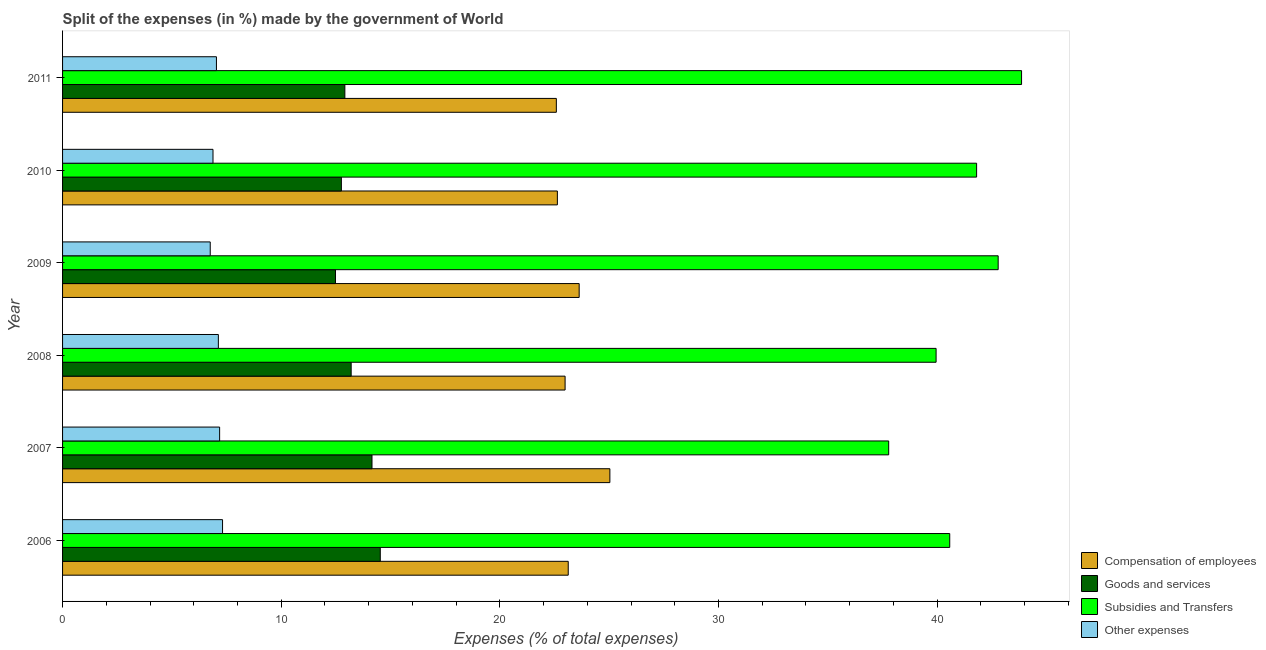How many groups of bars are there?
Your response must be concise. 6. How many bars are there on the 4th tick from the top?
Your response must be concise. 4. In how many cases, is the number of bars for a given year not equal to the number of legend labels?
Offer a terse response. 0. What is the percentage of amount spent on compensation of employees in 2011?
Offer a very short reply. 22.58. Across all years, what is the maximum percentage of amount spent on goods and services?
Ensure brevity in your answer.  14.53. Across all years, what is the minimum percentage of amount spent on other expenses?
Provide a short and direct response. 6.75. In which year was the percentage of amount spent on other expenses maximum?
Your answer should be very brief. 2006. What is the total percentage of amount spent on goods and services in the graph?
Your answer should be compact. 80.03. What is the difference between the percentage of amount spent on other expenses in 2006 and that in 2008?
Offer a terse response. 0.19. What is the difference between the percentage of amount spent on compensation of employees in 2006 and the percentage of amount spent on other expenses in 2011?
Make the answer very short. 16.09. What is the average percentage of amount spent on goods and services per year?
Keep it short and to the point. 13.34. In the year 2010, what is the difference between the percentage of amount spent on subsidies and percentage of amount spent on goods and services?
Your answer should be compact. 29.05. What is the ratio of the percentage of amount spent on goods and services in 2006 to that in 2007?
Your answer should be compact. 1.03. What is the difference between the highest and the second highest percentage of amount spent on goods and services?
Your answer should be compact. 0.38. What is the difference between the highest and the lowest percentage of amount spent on compensation of employees?
Keep it short and to the point. 2.45. In how many years, is the percentage of amount spent on goods and services greater than the average percentage of amount spent on goods and services taken over all years?
Keep it short and to the point. 2. What does the 4th bar from the top in 2008 represents?
Make the answer very short. Compensation of employees. What does the 4th bar from the bottom in 2010 represents?
Your answer should be very brief. Other expenses. How many bars are there?
Provide a succinct answer. 24. Are all the bars in the graph horizontal?
Offer a terse response. Yes. How many years are there in the graph?
Your answer should be very brief. 6. What is the difference between two consecutive major ticks on the X-axis?
Your answer should be compact. 10. Are the values on the major ticks of X-axis written in scientific E-notation?
Your answer should be very brief. No. Does the graph contain any zero values?
Your answer should be compact. No. Where does the legend appear in the graph?
Offer a very short reply. Bottom right. How many legend labels are there?
Provide a succinct answer. 4. How are the legend labels stacked?
Provide a succinct answer. Vertical. What is the title of the graph?
Make the answer very short. Split of the expenses (in %) made by the government of World. What is the label or title of the X-axis?
Provide a succinct answer. Expenses (% of total expenses). What is the label or title of the Y-axis?
Your answer should be very brief. Year. What is the Expenses (% of total expenses) in Compensation of employees in 2006?
Your answer should be very brief. 23.13. What is the Expenses (% of total expenses) in Goods and services in 2006?
Make the answer very short. 14.53. What is the Expenses (% of total expenses) of Subsidies and Transfers in 2006?
Give a very brief answer. 40.58. What is the Expenses (% of total expenses) of Other expenses in 2006?
Offer a terse response. 7.32. What is the Expenses (% of total expenses) of Compensation of employees in 2007?
Offer a terse response. 25.03. What is the Expenses (% of total expenses) of Goods and services in 2007?
Your answer should be compact. 14.15. What is the Expenses (% of total expenses) of Subsidies and Transfers in 2007?
Provide a succinct answer. 37.79. What is the Expenses (% of total expenses) of Other expenses in 2007?
Give a very brief answer. 7.18. What is the Expenses (% of total expenses) of Compensation of employees in 2008?
Your answer should be very brief. 22.98. What is the Expenses (% of total expenses) of Goods and services in 2008?
Make the answer very short. 13.2. What is the Expenses (% of total expenses) in Subsidies and Transfers in 2008?
Keep it short and to the point. 39.95. What is the Expenses (% of total expenses) in Other expenses in 2008?
Your response must be concise. 7.13. What is the Expenses (% of total expenses) in Compensation of employees in 2009?
Provide a short and direct response. 23.63. What is the Expenses (% of total expenses) in Goods and services in 2009?
Provide a succinct answer. 12.48. What is the Expenses (% of total expenses) in Subsidies and Transfers in 2009?
Give a very brief answer. 42.79. What is the Expenses (% of total expenses) in Other expenses in 2009?
Your response must be concise. 6.75. What is the Expenses (% of total expenses) in Compensation of employees in 2010?
Keep it short and to the point. 22.63. What is the Expenses (% of total expenses) in Goods and services in 2010?
Provide a succinct answer. 12.75. What is the Expenses (% of total expenses) in Subsidies and Transfers in 2010?
Provide a succinct answer. 41.81. What is the Expenses (% of total expenses) of Other expenses in 2010?
Your answer should be compact. 6.88. What is the Expenses (% of total expenses) in Compensation of employees in 2011?
Provide a short and direct response. 22.58. What is the Expenses (% of total expenses) of Goods and services in 2011?
Make the answer very short. 12.91. What is the Expenses (% of total expenses) of Subsidies and Transfers in 2011?
Keep it short and to the point. 43.86. What is the Expenses (% of total expenses) in Other expenses in 2011?
Provide a succinct answer. 7.04. Across all years, what is the maximum Expenses (% of total expenses) in Compensation of employees?
Ensure brevity in your answer.  25.03. Across all years, what is the maximum Expenses (% of total expenses) of Goods and services?
Offer a very short reply. 14.53. Across all years, what is the maximum Expenses (% of total expenses) of Subsidies and Transfers?
Your response must be concise. 43.86. Across all years, what is the maximum Expenses (% of total expenses) in Other expenses?
Your answer should be compact. 7.32. Across all years, what is the minimum Expenses (% of total expenses) in Compensation of employees?
Your answer should be compact. 22.58. Across all years, what is the minimum Expenses (% of total expenses) in Goods and services?
Ensure brevity in your answer.  12.48. Across all years, what is the minimum Expenses (% of total expenses) of Subsidies and Transfers?
Give a very brief answer. 37.79. Across all years, what is the minimum Expenses (% of total expenses) of Other expenses?
Your answer should be compact. 6.75. What is the total Expenses (% of total expenses) in Compensation of employees in the graph?
Your answer should be compact. 139.99. What is the total Expenses (% of total expenses) of Goods and services in the graph?
Make the answer very short. 80.03. What is the total Expenses (% of total expenses) of Subsidies and Transfers in the graph?
Offer a very short reply. 246.78. What is the total Expenses (% of total expenses) in Other expenses in the graph?
Provide a succinct answer. 42.3. What is the difference between the Expenses (% of total expenses) of Compensation of employees in 2006 and that in 2007?
Make the answer very short. -1.9. What is the difference between the Expenses (% of total expenses) in Goods and services in 2006 and that in 2007?
Ensure brevity in your answer.  0.38. What is the difference between the Expenses (% of total expenses) of Subsidies and Transfers in 2006 and that in 2007?
Give a very brief answer. 2.79. What is the difference between the Expenses (% of total expenses) in Other expenses in 2006 and that in 2007?
Provide a short and direct response. 0.13. What is the difference between the Expenses (% of total expenses) of Compensation of employees in 2006 and that in 2008?
Give a very brief answer. 0.14. What is the difference between the Expenses (% of total expenses) of Goods and services in 2006 and that in 2008?
Ensure brevity in your answer.  1.33. What is the difference between the Expenses (% of total expenses) in Subsidies and Transfers in 2006 and that in 2008?
Ensure brevity in your answer.  0.62. What is the difference between the Expenses (% of total expenses) of Other expenses in 2006 and that in 2008?
Give a very brief answer. 0.19. What is the difference between the Expenses (% of total expenses) of Compensation of employees in 2006 and that in 2009?
Make the answer very short. -0.5. What is the difference between the Expenses (% of total expenses) of Goods and services in 2006 and that in 2009?
Offer a very short reply. 2.05. What is the difference between the Expenses (% of total expenses) of Subsidies and Transfers in 2006 and that in 2009?
Your answer should be very brief. -2.22. What is the difference between the Expenses (% of total expenses) in Other expenses in 2006 and that in 2009?
Give a very brief answer. 0.56. What is the difference between the Expenses (% of total expenses) of Compensation of employees in 2006 and that in 2010?
Your answer should be very brief. 0.5. What is the difference between the Expenses (% of total expenses) of Goods and services in 2006 and that in 2010?
Make the answer very short. 1.78. What is the difference between the Expenses (% of total expenses) in Subsidies and Transfers in 2006 and that in 2010?
Provide a short and direct response. -1.23. What is the difference between the Expenses (% of total expenses) in Other expenses in 2006 and that in 2010?
Offer a very short reply. 0.44. What is the difference between the Expenses (% of total expenses) in Compensation of employees in 2006 and that in 2011?
Provide a short and direct response. 0.54. What is the difference between the Expenses (% of total expenses) in Goods and services in 2006 and that in 2011?
Your response must be concise. 1.62. What is the difference between the Expenses (% of total expenses) of Subsidies and Transfers in 2006 and that in 2011?
Provide a succinct answer. -3.29. What is the difference between the Expenses (% of total expenses) in Other expenses in 2006 and that in 2011?
Your answer should be compact. 0.28. What is the difference between the Expenses (% of total expenses) in Compensation of employees in 2007 and that in 2008?
Ensure brevity in your answer.  2.05. What is the difference between the Expenses (% of total expenses) of Goods and services in 2007 and that in 2008?
Your answer should be compact. 0.95. What is the difference between the Expenses (% of total expenses) in Subsidies and Transfers in 2007 and that in 2008?
Give a very brief answer. -2.17. What is the difference between the Expenses (% of total expenses) in Other expenses in 2007 and that in 2008?
Provide a short and direct response. 0.06. What is the difference between the Expenses (% of total expenses) in Compensation of employees in 2007 and that in 2009?
Provide a succinct answer. 1.4. What is the difference between the Expenses (% of total expenses) in Goods and services in 2007 and that in 2009?
Provide a succinct answer. 1.67. What is the difference between the Expenses (% of total expenses) of Subsidies and Transfers in 2007 and that in 2009?
Your answer should be very brief. -5.01. What is the difference between the Expenses (% of total expenses) of Other expenses in 2007 and that in 2009?
Your response must be concise. 0.43. What is the difference between the Expenses (% of total expenses) in Compensation of employees in 2007 and that in 2010?
Your answer should be very brief. 2.4. What is the difference between the Expenses (% of total expenses) of Goods and services in 2007 and that in 2010?
Make the answer very short. 1.4. What is the difference between the Expenses (% of total expenses) of Subsidies and Transfers in 2007 and that in 2010?
Offer a terse response. -4.02. What is the difference between the Expenses (% of total expenses) of Other expenses in 2007 and that in 2010?
Give a very brief answer. 0.3. What is the difference between the Expenses (% of total expenses) in Compensation of employees in 2007 and that in 2011?
Provide a succinct answer. 2.45. What is the difference between the Expenses (% of total expenses) in Goods and services in 2007 and that in 2011?
Your response must be concise. 1.24. What is the difference between the Expenses (% of total expenses) in Subsidies and Transfers in 2007 and that in 2011?
Provide a succinct answer. -6.08. What is the difference between the Expenses (% of total expenses) of Other expenses in 2007 and that in 2011?
Offer a very short reply. 0.15. What is the difference between the Expenses (% of total expenses) in Compensation of employees in 2008 and that in 2009?
Offer a very short reply. -0.64. What is the difference between the Expenses (% of total expenses) of Goods and services in 2008 and that in 2009?
Your answer should be compact. 0.72. What is the difference between the Expenses (% of total expenses) in Subsidies and Transfers in 2008 and that in 2009?
Your answer should be very brief. -2.84. What is the difference between the Expenses (% of total expenses) of Other expenses in 2008 and that in 2009?
Make the answer very short. 0.37. What is the difference between the Expenses (% of total expenses) in Compensation of employees in 2008 and that in 2010?
Ensure brevity in your answer.  0.35. What is the difference between the Expenses (% of total expenses) in Goods and services in 2008 and that in 2010?
Ensure brevity in your answer.  0.45. What is the difference between the Expenses (% of total expenses) of Subsidies and Transfers in 2008 and that in 2010?
Make the answer very short. -1.85. What is the difference between the Expenses (% of total expenses) of Other expenses in 2008 and that in 2010?
Ensure brevity in your answer.  0.24. What is the difference between the Expenses (% of total expenses) of Compensation of employees in 2008 and that in 2011?
Keep it short and to the point. 0.4. What is the difference between the Expenses (% of total expenses) in Goods and services in 2008 and that in 2011?
Make the answer very short. 0.29. What is the difference between the Expenses (% of total expenses) of Subsidies and Transfers in 2008 and that in 2011?
Make the answer very short. -3.91. What is the difference between the Expenses (% of total expenses) of Other expenses in 2008 and that in 2011?
Provide a short and direct response. 0.09. What is the difference between the Expenses (% of total expenses) of Compensation of employees in 2009 and that in 2010?
Your response must be concise. 1. What is the difference between the Expenses (% of total expenses) in Goods and services in 2009 and that in 2010?
Keep it short and to the point. -0.27. What is the difference between the Expenses (% of total expenses) of Other expenses in 2009 and that in 2010?
Keep it short and to the point. -0.13. What is the difference between the Expenses (% of total expenses) of Compensation of employees in 2009 and that in 2011?
Your answer should be very brief. 1.04. What is the difference between the Expenses (% of total expenses) in Goods and services in 2009 and that in 2011?
Ensure brevity in your answer.  -0.43. What is the difference between the Expenses (% of total expenses) of Subsidies and Transfers in 2009 and that in 2011?
Offer a very short reply. -1.07. What is the difference between the Expenses (% of total expenses) of Other expenses in 2009 and that in 2011?
Ensure brevity in your answer.  -0.28. What is the difference between the Expenses (% of total expenses) in Compensation of employees in 2010 and that in 2011?
Offer a terse response. 0.05. What is the difference between the Expenses (% of total expenses) in Goods and services in 2010 and that in 2011?
Your response must be concise. -0.16. What is the difference between the Expenses (% of total expenses) of Subsidies and Transfers in 2010 and that in 2011?
Your answer should be compact. -2.06. What is the difference between the Expenses (% of total expenses) in Other expenses in 2010 and that in 2011?
Provide a succinct answer. -0.16. What is the difference between the Expenses (% of total expenses) in Compensation of employees in 2006 and the Expenses (% of total expenses) in Goods and services in 2007?
Keep it short and to the point. 8.98. What is the difference between the Expenses (% of total expenses) in Compensation of employees in 2006 and the Expenses (% of total expenses) in Subsidies and Transfers in 2007?
Give a very brief answer. -14.66. What is the difference between the Expenses (% of total expenses) of Compensation of employees in 2006 and the Expenses (% of total expenses) of Other expenses in 2007?
Your answer should be compact. 15.94. What is the difference between the Expenses (% of total expenses) of Goods and services in 2006 and the Expenses (% of total expenses) of Subsidies and Transfers in 2007?
Ensure brevity in your answer.  -23.25. What is the difference between the Expenses (% of total expenses) of Goods and services in 2006 and the Expenses (% of total expenses) of Other expenses in 2007?
Ensure brevity in your answer.  7.35. What is the difference between the Expenses (% of total expenses) of Subsidies and Transfers in 2006 and the Expenses (% of total expenses) of Other expenses in 2007?
Keep it short and to the point. 33.39. What is the difference between the Expenses (% of total expenses) of Compensation of employees in 2006 and the Expenses (% of total expenses) of Goods and services in 2008?
Provide a short and direct response. 9.93. What is the difference between the Expenses (% of total expenses) of Compensation of employees in 2006 and the Expenses (% of total expenses) of Subsidies and Transfers in 2008?
Offer a very short reply. -16.83. What is the difference between the Expenses (% of total expenses) of Compensation of employees in 2006 and the Expenses (% of total expenses) of Other expenses in 2008?
Offer a very short reply. 16. What is the difference between the Expenses (% of total expenses) of Goods and services in 2006 and the Expenses (% of total expenses) of Subsidies and Transfers in 2008?
Your answer should be compact. -25.42. What is the difference between the Expenses (% of total expenses) of Goods and services in 2006 and the Expenses (% of total expenses) of Other expenses in 2008?
Offer a very short reply. 7.41. What is the difference between the Expenses (% of total expenses) of Subsidies and Transfers in 2006 and the Expenses (% of total expenses) of Other expenses in 2008?
Ensure brevity in your answer.  33.45. What is the difference between the Expenses (% of total expenses) of Compensation of employees in 2006 and the Expenses (% of total expenses) of Goods and services in 2009?
Your response must be concise. 10.65. What is the difference between the Expenses (% of total expenses) in Compensation of employees in 2006 and the Expenses (% of total expenses) in Subsidies and Transfers in 2009?
Provide a succinct answer. -19.66. What is the difference between the Expenses (% of total expenses) of Compensation of employees in 2006 and the Expenses (% of total expenses) of Other expenses in 2009?
Your answer should be compact. 16.37. What is the difference between the Expenses (% of total expenses) of Goods and services in 2006 and the Expenses (% of total expenses) of Subsidies and Transfers in 2009?
Your answer should be very brief. -28.26. What is the difference between the Expenses (% of total expenses) in Goods and services in 2006 and the Expenses (% of total expenses) in Other expenses in 2009?
Your response must be concise. 7.78. What is the difference between the Expenses (% of total expenses) of Subsidies and Transfers in 2006 and the Expenses (% of total expenses) of Other expenses in 2009?
Offer a very short reply. 33.82. What is the difference between the Expenses (% of total expenses) of Compensation of employees in 2006 and the Expenses (% of total expenses) of Goods and services in 2010?
Give a very brief answer. 10.38. What is the difference between the Expenses (% of total expenses) in Compensation of employees in 2006 and the Expenses (% of total expenses) in Subsidies and Transfers in 2010?
Give a very brief answer. -18.68. What is the difference between the Expenses (% of total expenses) of Compensation of employees in 2006 and the Expenses (% of total expenses) of Other expenses in 2010?
Your answer should be compact. 16.25. What is the difference between the Expenses (% of total expenses) in Goods and services in 2006 and the Expenses (% of total expenses) in Subsidies and Transfers in 2010?
Give a very brief answer. -27.27. What is the difference between the Expenses (% of total expenses) in Goods and services in 2006 and the Expenses (% of total expenses) in Other expenses in 2010?
Your response must be concise. 7.65. What is the difference between the Expenses (% of total expenses) in Subsidies and Transfers in 2006 and the Expenses (% of total expenses) in Other expenses in 2010?
Ensure brevity in your answer.  33.7. What is the difference between the Expenses (% of total expenses) of Compensation of employees in 2006 and the Expenses (% of total expenses) of Goods and services in 2011?
Your response must be concise. 10.22. What is the difference between the Expenses (% of total expenses) in Compensation of employees in 2006 and the Expenses (% of total expenses) in Subsidies and Transfers in 2011?
Ensure brevity in your answer.  -20.73. What is the difference between the Expenses (% of total expenses) in Compensation of employees in 2006 and the Expenses (% of total expenses) in Other expenses in 2011?
Offer a terse response. 16.09. What is the difference between the Expenses (% of total expenses) of Goods and services in 2006 and the Expenses (% of total expenses) of Subsidies and Transfers in 2011?
Provide a short and direct response. -29.33. What is the difference between the Expenses (% of total expenses) of Goods and services in 2006 and the Expenses (% of total expenses) of Other expenses in 2011?
Offer a terse response. 7.49. What is the difference between the Expenses (% of total expenses) in Subsidies and Transfers in 2006 and the Expenses (% of total expenses) in Other expenses in 2011?
Make the answer very short. 33.54. What is the difference between the Expenses (% of total expenses) in Compensation of employees in 2007 and the Expenses (% of total expenses) in Goods and services in 2008?
Your answer should be compact. 11.83. What is the difference between the Expenses (% of total expenses) of Compensation of employees in 2007 and the Expenses (% of total expenses) of Subsidies and Transfers in 2008?
Offer a very short reply. -14.92. What is the difference between the Expenses (% of total expenses) of Compensation of employees in 2007 and the Expenses (% of total expenses) of Other expenses in 2008?
Offer a terse response. 17.91. What is the difference between the Expenses (% of total expenses) in Goods and services in 2007 and the Expenses (% of total expenses) in Subsidies and Transfers in 2008?
Your answer should be very brief. -25.8. What is the difference between the Expenses (% of total expenses) of Goods and services in 2007 and the Expenses (% of total expenses) of Other expenses in 2008?
Offer a terse response. 7.03. What is the difference between the Expenses (% of total expenses) in Subsidies and Transfers in 2007 and the Expenses (% of total expenses) in Other expenses in 2008?
Your answer should be very brief. 30.66. What is the difference between the Expenses (% of total expenses) of Compensation of employees in 2007 and the Expenses (% of total expenses) of Goods and services in 2009?
Provide a succinct answer. 12.55. What is the difference between the Expenses (% of total expenses) in Compensation of employees in 2007 and the Expenses (% of total expenses) in Subsidies and Transfers in 2009?
Keep it short and to the point. -17.76. What is the difference between the Expenses (% of total expenses) of Compensation of employees in 2007 and the Expenses (% of total expenses) of Other expenses in 2009?
Your response must be concise. 18.28. What is the difference between the Expenses (% of total expenses) of Goods and services in 2007 and the Expenses (% of total expenses) of Subsidies and Transfers in 2009?
Your answer should be compact. -28.64. What is the difference between the Expenses (% of total expenses) of Goods and services in 2007 and the Expenses (% of total expenses) of Other expenses in 2009?
Provide a short and direct response. 7.4. What is the difference between the Expenses (% of total expenses) of Subsidies and Transfers in 2007 and the Expenses (% of total expenses) of Other expenses in 2009?
Offer a terse response. 31.03. What is the difference between the Expenses (% of total expenses) in Compensation of employees in 2007 and the Expenses (% of total expenses) in Goods and services in 2010?
Offer a terse response. 12.28. What is the difference between the Expenses (% of total expenses) in Compensation of employees in 2007 and the Expenses (% of total expenses) in Subsidies and Transfers in 2010?
Offer a terse response. -16.77. What is the difference between the Expenses (% of total expenses) of Compensation of employees in 2007 and the Expenses (% of total expenses) of Other expenses in 2010?
Offer a very short reply. 18.15. What is the difference between the Expenses (% of total expenses) of Goods and services in 2007 and the Expenses (% of total expenses) of Subsidies and Transfers in 2010?
Make the answer very short. -27.65. What is the difference between the Expenses (% of total expenses) in Goods and services in 2007 and the Expenses (% of total expenses) in Other expenses in 2010?
Your answer should be compact. 7.27. What is the difference between the Expenses (% of total expenses) in Subsidies and Transfers in 2007 and the Expenses (% of total expenses) in Other expenses in 2010?
Offer a terse response. 30.9. What is the difference between the Expenses (% of total expenses) of Compensation of employees in 2007 and the Expenses (% of total expenses) of Goods and services in 2011?
Your answer should be compact. 12.12. What is the difference between the Expenses (% of total expenses) in Compensation of employees in 2007 and the Expenses (% of total expenses) in Subsidies and Transfers in 2011?
Offer a terse response. -18.83. What is the difference between the Expenses (% of total expenses) of Compensation of employees in 2007 and the Expenses (% of total expenses) of Other expenses in 2011?
Make the answer very short. 17.99. What is the difference between the Expenses (% of total expenses) in Goods and services in 2007 and the Expenses (% of total expenses) in Subsidies and Transfers in 2011?
Your response must be concise. -29.71. What is the difference between the Expenses (% of total expenses) in Goods and services in 2007 and the Expenses (% of total expenses) in Other expenses in 2011?
Make the answer very short. 7.12. What is the difference between the Expenses (% of total expenses) of Subsidies and Transfers in 2007 and the Expenses (% of total expenses) of Other expenses in 2011?
Provide a short and direct response. 30.75. What is the difference between the Expenses (% of total expenses) in Compensation of employees in 2008 and the Expenses (% of total expenses) in Goods and services in 2009?
Provide a short and direct response. 10.5. What is the difference between the Expenses (% of total expenses) of Compensation of employees in 2008 and the Expenses (% of total expenses) of Subsidies and Transfers in 2009?
Offer a terse response. -19.81. What is the difference between the Expenses (% of total expenses) in Compensation of employees in 2008 and the Expenses (% of total expenses) in Other expenses in 2009?
Provide a succinct answer. 16.23. What is the difference between the Expenses (% of total expenses) of Goods and services in 2008 and the Expenses (% of total expenses) of Subsidies and Transfers in 2009?
Offer a very short reply. -29.59. What is the difference between the Expenses (% of total expenses) of Goods and services in 2008 and the Expenses (% of total expenses) of Other expenses in 2009?
Your response must be concise. 6.45. What is the difference between the Expenses (% of total expenses) in Subsidies and Transfers in 2008 and the Expenses (% of total expenses) in Other expenses in 2009?
Keep it short and to the point. 33.2. What is the difference between the Expenses (% of total expenses) of Compensation of employees in 2008 and the Expenses (% of total expenses) of Goods and services in 2010?
Offer a very short reply. 10.23. What is the difference between the Expenses (% of total expenses) of Compensation of employees in 2008 and the Expenses (% of total expenses) of Subsidies and Transfers in 2010?
Make the answer very short. -18.82. What is the difference between the Expenses (% of total expenses) in Compensation of employees in 2008 and the Expenses (% of total expenses) in Other expenses in 2010?
Your response must be concise. 16.1. What is the difference between the Expenses (% of total expenses) in Goods and services in 2008 and the Expenses (% of total expenses) in Subsidies and Transfers in 2010?
Give a very brief answer. -28.61. What is the difference between the Expenses (% of total expenses) of Goods and services in 2008 and the Expenses (% of total expenses) of Other expenses in 2010?
Provide a succinct answer. 6.32. What is the difference between the Expenses (% of total expenses) in Subsidies and Transfers in 2008 and the Expenses (% of total expenses) in Other expenses in 2010?
Keep it short and to the point. 33.07. What is the difference between the Expenses (% of total expenses) of Compensation of employees in 2008 and the Expenses (% of total expenses) of Goods and services in 2011?
Offer a very short reply. 10.07. What is the difference between the Expenses (% of total expenses) of Compensation of employees in 2008 and the Expenses (% of total expenses) of Subsidies and Transfers in 2011?
Your response must be concise. -20.88. What is the difference between the Expenses (% of total expenses) in Compensation of employees in 2008 and the Expenses (% of total expenses) in Other expenses in 2011?
Offer a very short reply. 15.95. What is the difference between the Expenses (% of total expenses) in Goods and services in 2008 and the Expenses (% of total expenses) in Subsidies and Transfers in 2011?
Give a very brief answer. -30.66. What is the difference between the Expenses (% of total expenses) in Goods and services in 2008 and the Expenses (% of total expenses) in Other expenses in 2011?
Your answer should be very brief. 6.16. What is the difference between the Expenses (% of total expenses) in Subsidies and Transfers in 2008 and the Expenses (% of total expenses) in Other expenses in 2011?
Keep it short and to the point. 32.92. What is the difference between the Expenses (% of total expenses) in Compensation of employees in 2009 and the Expenses (% of total expenses) in Goods and services in 2010?
Your answer should be very brief. 10.88. What is the difference between the Expenses (% of total expenses) of Compensation of employees in 2009 and the Expenses (% of total expenses) of Subsidies and Transfers in 2010?
Your answer should be very brief. -18.18. What is the difference between the Expenses (% of total expenses) of Compensation of employees in 2009 and the Expenses (% of total expenses) of Other expenses in 2010?
Keep it short and to the point. 16.75. What is the difference between the Expenses (% of total expenses) of Goods and services in 2009 and the Expenses (% of total expenses) of Subsidies and Transfers in 2010?
Ensure brevity in your answer.  -29.32. What is the difference between the Expenses (% of total expenses) in Goods and services in 2009 and the Expenses (% of total expenses) in Other expenses in 2010?
Make the answer very short. 5.6. What is the difference between the Expenses (% of total expenses) of Subsidies and Transfers in 2009 and the Expenses (% of total expenses) of Other expenses in 2010?
Provide a succinct answer. 35.91. What is the difference between the Expenses (% of total expenses) of Compensation of employees in 2009 and the Expenses (% of total expenses) of Goods and services in 2011?
Make the answer very short. 10.72. What is the difference between the Expenses (% of total expenses) in Compensation of employees in 2009 and the Expenses (% of total expenses) in Subsidies and Transfers in 2011?
Your response must be concise. -20.23. What is the difference between the Expenses (% of total expenses) of Compensation of employees in 2009 and the Expenses (% of total expenses) of Other expenses in 2011?
Provide a short and direct response. 16.59. What is the difference between the Expenses (% of total expenses) in Goods and services in 2009 and the Expenses (% of total expenses) in Subsidies and Transfers in 2011?
Make the answer very short. -31.38. What is the difference between the Expenses (% of total expenses) of Goods and services in 2009 and the Expenses (% of total expenses) of Other expenses in 2011?
Give a very brief answer. 5.44. What is the difference between the Expenses (% of total expenses) in Subsidies and Transfers in 2009 and the Expenses (% of total expenses) in Other expenses in 2011?
Provide a short and direct response. 35.75. What is the difference between the Expenses (% of total expenses) of Compensation of employees in 2010 and the Expenses (% of total expenses) of Goods and services in 2011?
Offer a terse response. 9.72. What is the difference between the Expenses (% of total expenses) of Compensation of employees in 2010 and the Expenses (% of total expenses) of Subsidies and Transfers in 2011?
Make the answer very short. -21.23. What is the difference between the Expenses (% of total expenses) of Compensation of employees in 2010 and the Expenses (% of total expenses) of Other expenses in 2011?
Your answer should be compact. 15.59. What is the difference between the Expenses (% of total expenses) in Goods and services in 2010 and the Expenses (% of total expenses) in Subsidies and Transfers in 2011?
Your answer should be compact. -31.11. What is the difference between the Expenses (% of total expenses) in Goods and services in 2010 and the Expenses (% of total expenses) in Other expenses in 2011?
Ensure brevity in your answer.  5.71. What is the difference between the Expenses (% of total expenses) of Subsidies and Transfers in 2010 and the Expenses (% of total expenses) of Other expenses in 2011?
Your answer should be compact. 34.77. What is the average Expenses (% of total expenses) of Compensation of employees per year?
Keep it short and to the point. 23.33. What is the average Expenses (% of total expenses) in Goods and services per year?
Your answer should be compact. 13.34. What is the average Expenses (% of total expenses) in Subsidies and Transfers per year?
Offer a very short reply. 41.13. What is the average Expenses (% of total expenses) in Other expenses per year?
Make the answer very short. 7.05. In the year 2006, what is the difference between the Expenses (% of total expenses) of Compensation of employees and Expenses (% of total expenses) of Goods and services?
Your answer should be very brief. 8.6. In the year 2006, what is the difference between the Expenses (% of total expenses) of Compensation of employees and Expenses (% of total expenses) of Subsidies and Transfers?
Give a very brief answer. -17.45. In the year 2006, what is the difference between the Expenses (% of total expenses) in Compensation of employees and Expenses (% of total expenses) in Other expenses?
Provide a short and direct response. 15.81. In the year 2006, what is the difference between the Expenses (% of total expenses) in Goods and services and Expenses (% of total expenses) in Subsidies and Transfers?
Ensure brevity in your answer.  -26.05. In the year 2006, what is the difference between the Expenses (% of total expenses) in Goods and services and Expenses (% of total expenses) in Other expenses?
Provide a succinct answer. 7.21. In the year 2006, what is the difference between the Expenses (% of total expenses) in Subsidies and Transfers and Expenses (% of total expenses) in Other expenses?
Offer a terse response. 33.26. In the year 2007, what is the difference between the Expenses (% of total expenses) of Compensation of employees and Expenses (% of total expenses) of Goods and services?
Give a very brief answer. 10.88. In the year 2007, what is the difference between the Expenses (% of total expenses) of Compensation of employees and Expenses (% of total expenses) of Subsidies and Transfers?
Keep it short and to the point. -12.75. In the year 2007, what is the difference between the Expenses (% of total expenses) in Compensation of employees and Expenses (% of total expenses) in Other expenses?
Make the answer very short. 17.85. In the year 2007, what is the difference between the Expenses (% of total expenses) of Goods and services and Expenses (% of total expenses) of Subsidies and Transfers?
Your answer should be compact. -23.63. In the year 2007, what is the difference between the Expenses (% of total expenses) in Goods and services and Expenses (% of total expenses) in Other expenses?
Your answer should be very brief. 6.97. In the year 2007, what is the difference between the Expenses (% of total expenses) of Subsidies and Transfers and Expenses (% of total expenses) of Other expenses?
Make the answer very short. 30.6. In the year 2008, what is the difference between the Expenses (% of total expenses) in Compensation of employees and Expenses (% of total expenses) in Goods and services?
Offer a terse response. 9.78. In the year 2008, what is the difference between the Expenses (% of total expenses) in Compensation of employees and Expenses (% of total expenses) in Subsidies and Transfers?
Your response must be concise. -16.97. In the year 2008, what is the difference between the Expenses (% of total expenses) in Compensation of employees and Expenses (% of total expenses) in Other expenses?
Offer a very short reply. 15.86. In the year 2008, what is the difference between the Expenses (% of total expenses) in Goods and services and Expenses (% of total expenses) in Subsidies and Transfers?
Provide a short and direct response. -26.75. In the year 2008, what is the difference between the Expenses (% of total expenses) of Goods and services and Expenses (% of total expenses) of Other expenses?
Offer a terse response. 6.07. In the year 2008, what is the difference between the Expenses (% of total expenses) of Subsidies and Transfers and Expenses (% of total expenses) of Other expenses?
Offer a terse response. 32.83. In the year 2009, what is the difference between the Expenses (% of total expenses) in Compensation of employees and Expenses (% of total expenses) in Goods and services?
Your answer should be very brief. 11.15. In the year 2009, what is the difference between the Expenses (% of total expenses) of Compensation of employees and Expenses (% of total expenses) of Subsidies and Transfers?
Ensure brevity in your answer.  -19.16. In the year 2009, what is the difference between the Expenses (% of total expenses) of Compensation of employees and Expenses (% of total expenses) of Other expenses?
Offer a very short reply. 16.87. In the year 2009, what is the difference between the Expenses (% of total expenses) of Goods and services and Expenses (% of total expenses) of Subsidies and Transfers?
Make the answer very short. -30.31. In the year 2009, what is the difference between the Expenses (% of total expenses) in Goods and services and Expenses (% of total expenses) in Other expenses?
Offer a terse response. 5.73. In the year 2009, what is the difference between the Expenses (% of total expenses) in Subsidies and Transfers and Expenses (% of total expenses) in Other expenses?
Your answer should be compact. 36.04. In the year 2010, what is the difference between the Expenses (% of total expenses) of Compensation of employees and Expenses (% of total expenses) of Goods and services?
Your answer should be compact. 9.88. In the year 2010, what is the difference between the Expenses (% of total expenses) in Compensation of employees and Expenses (% of total expenses) in Subsidies and Transfers?
Offer a very short reply. -19.18. In the year 2010, what is the difference between the Expenses (% of total expenses) of Compensation of employees and Expenses (% of total expenses) of Other expenses?
Provide a succinct answer. 15.75. In the year 2010, what is the difference between the Expenses (% of total expenses) of Goods and services and Expenses (% of total expenses) of Subsidies and Transfers?
Make the answer very short. -29.05. In the year 2010, what is the difference between the Expenses (% of total expenses) in Goods and services and Expenses (% of total expenses) in Other expenses?
Your answer should be compact. 5.87. In the year 2010, what is the difference between the Expenses (% of total expenses) in Subsidies and Transfers and Expenses (% of total expenses) in Other expenses?
Ensure brevity in your answer.  34.93. In the year 2011, what is the difference between the Expenses (% of total expenses) in Compensation of employees and Expenses (% of total expenses) in Goods and services?
Make the answer very short. 9.67. In the year 2011, what is the difference between the Expenses (% of total expenses) of Compensation of employees and Expenses (% of total expenses) of Subsidies and Transfers?
Your answer should be very brief. -21.28. In the year 2011, what is the difference between the Expenses (% of total expenses) of Compensation of employees and Expenses (% of total expenses) of Other expenses?
Your answer should be very brief. 15.55. In the year 2011, what is the difference between the Expenses (% of total expenses) of Goods and services and Expenses (% of total expenses) of Subsidies and Transfers?
Keep it short and to the point. -30.95. In the year 2011, what is the difference between the Expenses (% of total expenses) of Goods and services and Expenses (% of total expenses) of Other expenses?
Your answer should be very brief. 5.87. In the year 2011, what is the difference between the Expenses (% of total expenses) of Subsidies and Transfers and Expenses (% of total expenses) of Other expenses?
Keep it short and to the point. 36.82. What is the ratio of the Expenses (% of total expenses) in Compensation of employees in 2006 to that in 2007?
Your answer should be compact. 0.92. What is the ratio of the Expenses (% of total expenses) of Goods and services in 2006 to that in 2007?
Ensure brevity in your answer.  1.03. What is the ratio of the Expenses (% of total expenses) in Subsidies and Transfers in 2006 to that in 2007?
Provide a short and direct response. 1.07. What is the ratio of the Expenses (% of total expenses) of Other expenses in 2006 to that in 2007?
Keep it short and to the point. 1.02. What is the ratio of the Expenses (% of total expenses) of Compensation of employees in 2006 to that in 2008?
Give a very brief answer. 1.01. What is the ratio of the Expenses (% of total expenses) in Goods and services in 2006 to that in 2008?
Provide a succinct answer. 1.1. What is the ratio of the Expenses (% of total expenses) of Subsidies and Transfers in 2006 to that in 2008?
Your answer should be very brief. 1.02. What is the ratio of the Expenses (% of total expenses) in Other expenses in 2006 to that in 2008?
Keep it short and to the point. 1.03. What is the ratio of the Expenses (% of total expenses) of Compensation of employees in 2006 to that in 2009?
Offer a terse response. 0.98. What is the ratio of the Expenses (% of total expenses) in Goods and services in 2006 to that in 2009?
Your response must be concise. 1.16. What is the ratio of the Expenses (% of total expenses) of Subsidies and Transfers in 2006 to that in 2009?
Your response must be concise. 0.95. What is the ratio of the Expenses (% of total expenses) of Other expenses in 2006 to that in 2009?
Your answer should be very brief. 1.08. What is the ratio of the Expenses (% of total expenses) of Compensation of employees in 2006 to that in 2010?
Your answer should be very brief. 1.02. What is the ratio of the Expenses (% of total expenses) of Goods and services in 2006 to that in 2010?
Provide a succinct answer. 1.14. What is the ratio of the Expenses (% of total expenses) in Subsidies and Transfers in 2006 to that in 2010?
Provide a short and direct response. 0.97. What is the ratio of the Expenses (% of total expenses) in Other expenses in 2006 to that in 2010?
Make the answer very short. 1.06. What is the ratio of the Expenses (% of total expenses) of Compensation of employees in 2006 to that in 2011?
Your answer should be compact. 1.02. What is the ratio of the Expenses (% of total expenses) in Goods and services in 2006 to that in 2011?
Your response must be concise. 1.13. What is the ratio of the Expenses (% of total expenses) in Subsidies and Transfers in 2006 to that in 2011?
Keep it short and to the point. 0.93. What is the ratio of the Expenses (% of total expenses) in Other expenses in 2006 to that in 2011?
Make the answer very short. 1.04. What is the ratio of the Expenses (% of total expenses) in Compensation of employees in 2007 to that in 2008?
Offer a terse response. 1.09. What is the ratio of the Expenses (% of total expenses) in Goods and services in 2007 to that in 2008?
Give a very brief answer. 1.07. What is the ratio of the Expenses (% of total expenses) of Subsidies and Transfers in 2007 to that in 2008?
Your answer should be compact. 0.95. What is the ratio of the Expenses (% of total expenses) in Other expenses in 2007 to that in 2008?
Offer a very short reply. 1.01. What is the ratio of the Expenses (% of total expenses) in Compensation of employees in 2007 to that in 2009?
Provide a succinct answer. 1.06. What is the ratio of the Expenses (% of total expenses) of Goods and services in 2007 to that in 2009?
Provide a succinct answer. 1.13. What is the ratio of the Expenses (% of total expenses) in Subsidies and Transfers in 2007 to that in 2009?
Make the answer very short. 0.88. What is the ratio of the Expenses (% of total expenses) in Other expenses in 2007 to that in 2009?
Your response must be concise. 1.06. What is the ratio of the Expenses (% of total expenses) in Compensation of employees in 2007 to that in 2010?
Your response must be concise. 1.11. What is the ratio of the Expenses (% of total expenses) in Goods and services in 2007 to that in 2010?
Your answer should be compact. 1.11. What is the ratio of the Expenses (% of total expenses) of Subsidies and Transfers in 2007 to that in 2010?
Provide a short and direct response. 0.9. What is the ratio of the Expenses (% of total expenses) of Other expenses in 2007 to that in 2010?
Your answer should be very brief. 1.04. What is the ratio of the Expenses (% of total expenses) of Compensation of employees in 2007 to that in 2011?
Make the answer very short. 1.11. What is the ratio of the Expenses (% of total expenses) in Goods and services in 2007 to that in 2011?
Ensure brevity in your answer.  1.1. What is the ratio of the Expenses (% of total expenses) in Subsidies and Transfers in 2007 to that in 2011?
Make the answer very short. 0.86. What is the ratio of the Expenses (% of total expenses) in Other expenses in 2007 to that in 2011?
Ensure brevity in your answer.  1.02. What is the ratio of the Expenses (% of total expenses) of Compensation of employees in 2008 to that in 2009?
Offer a very short reply. 0.97. What is the ratio of the Expenses (% of total expenses) of Goods and services in 2008 to that in 2009?
Your answer should be compact. 1.06. What is the ratio of the Expenses (% of total expenses) of Subsidies and Transfers in 2008 to that in 2009?
Give a very brief answer. 0.93. What is the ratio of the Expenses (% of total expenses) of Other expenses in 2008 to that in 2009?
Provide a succinct answer. 1.05. What is the ratio of the Expenses (% of total expenses) in Compensation of employees in 2008 to that in 2010?
Give a very brief answer. 1.02. What is the ratio of the Expenses (% of total expenses) in Goods and services in 2008 to that in 2010?
Provide a succinct answer. 1.04. What is the ratio of the Expenses (% of total expenses) in Subsidies and Transfers in 2008 to that in 2010?
Ensure brevity in your answer.  0.96. What is the ratio of the Expenses (% of total expenses) in Other expenses in 2008 to that in 2010?
Keep it short and to the point. 1.04. What is the ratio of the Expenses (% of total expenses) of Compensation of employees in 2008 to that in 2011?
Provide a short and direct response. 1.02. What is the ratio of the Expenses (% of total expenses) of Goods and services in 2008 to that in 2011?
Provide a succinct answer. 1.02. What is the ratio of the Expenses (% of total expenses) of Subsidies and Transfers in 2008 to that in 2011?
Offer a terse response. 0.91. What is the ratio of the Expenses (% of total expenses) of Other expenses in 2008 to that in 2011?
Ensure brevity in your answer.  1.01. What is the ratio of the Expenses (% of total expenses) in Compensation of employees in 2009 to that in 2010?
Provide a succinct answer. 1.04. What is the ratio of the Expenses (% of total expenses) in Goods and services in 2009 to that in 2010?
Offer a terse response. 0.98. What is the ratio of the Expenses (% of total expenses) in Subsidies and Transfers in 2009 to that in 2010?
Keep it short and to the point. 1.02. What is the ratio of the Expenses (% of total expenses) of Other expenses in 2009 to that in 2010?
Your answer should be compact. 0.98. What is the ratio of the Expenses (% of total expenses) in Compensation of employees in 2009 to that in 2011?
Your answer should be very brief. 1.05. What is the ratio of the Expenses (% of total expenses) of Goods and services in 2009 to that in 2011?
Offer a terse response. 0.97. What is the ratio of the Expenses (% of total expenses) in Subsidies and Transfers in 2009 to that in 2011?
Provide a short and direct response. 0.98. What is the ratio of the Expenses (% of total expenses) of Other expenses in 2009 to that in 2011?
Offer a very short reply. 0.96. What is the ratio of the Expenses (% of total expenses) in Goods and services in 2010 to that in 2011?
Provide a short and direct response. 0.99. What is the ratio of the Expenses (% of total expenses) of Subsidies and Transfers in 2010 to that in 2011?
Keep it short and to the point. 0.95. What is the ratio of the Expenses (% of total expenses) of Other expenses in 2010 to that in 2011?
Provide a short and direct response. 0.98. What is the difference between the highest and the second highest Expenses (% of total expenses) in Compensation of employees?
Offer a very short reply. 1.4. What is the difference between the highest and the second highest Expenses (% of total expenses) of Goods and services?
Ensure brevity in your answer.  0.38. What is the difference between the highest and the second highest Expenses (% of total expenses) of Subsidies and Transfers?
Your response must be concise. 1.07. What is the difference between the highest and the second highest Expenses (% of total expenses) in Other expenses?
Provide a short and direct response. 0.13. What is the difference between the highest and the lowest Expenses (% of total expenses) in Compensation of employees?
Your response must be concise. 2.45. What is the difference between the highest and the lowest Expenses (% of total expenses) of Goods and services?
Offer a very short reply. 2.05. What is the difference between the highest and the lowest Expenses (% of total expenses) of Subsidies and Transfers?
Your answer should be compact. 6.08. What is the difference between the highest and the lowest Expenses (% of total expenses) in Other expenses?
Your response must be concise. 0.56. 